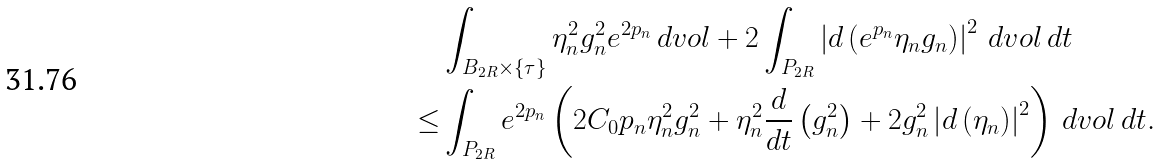Convert formula to latex. <formula><loc_0><loc_0><loc_500><loc_500>& \int _ { B _ { 2 R } \times \{ \tau \} } \eta _ { n } ^ { 2 } g _ { n } ^ { 2 } e ^ { 2 p _ { n } } \, d v o l + 2 \int _ { P _ { 2 R } } \left | d \left ( e ^ { p _ { n } } \eta _ { n } g _ { n } \right ) \right | ^ { 2 } \, d v o l \, d t \\ \leq & \int _ { P _ { 2 R } } e ^ { 2 p _ { n } } \left ( 2 C _ { 0 } p _ { n } \eta _ { n } ^ { 2 } g _ { n } ^ { 2 } + \eta _ { n } ^ { 2 } \frac { d } { d t } \left ( g _ { n } ^ { 2 } \right ) + 2 g _ { n } ^ { 2 } \left | d \left ( \eta _ { n } \right ) \right | ^ { 2 } \right ) \, d v o l \, d t .</formula> 